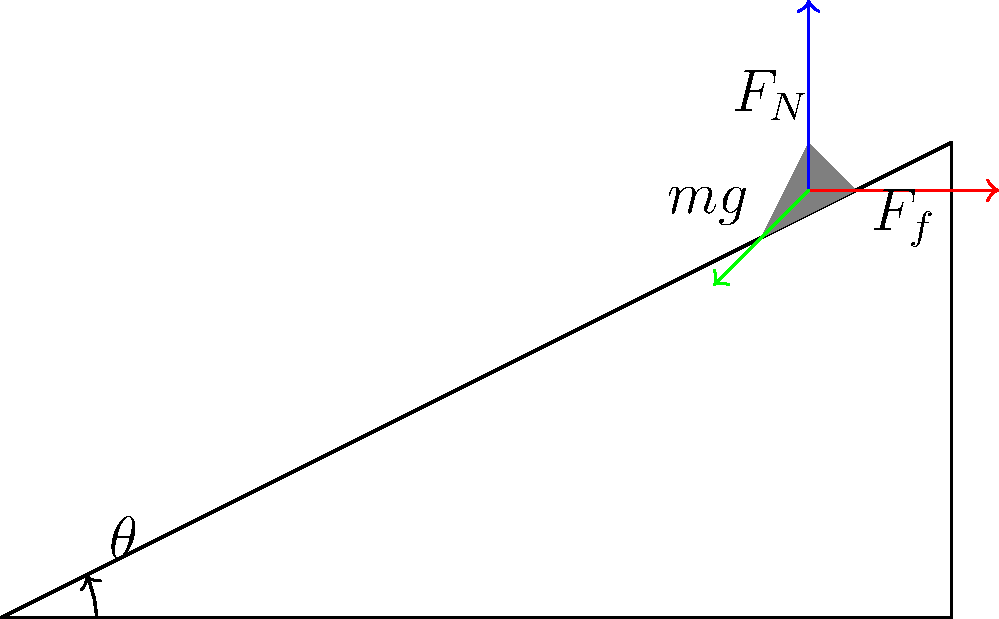In a protest rally, a megaphone is placed on an inclined surface with an angle $\theta$ to the horizontal. The mass of the megaphone is $m$. If the coefficient of static friction between the megaphone and the surface is $\mu_s$, what is the minimum angle $\theta$ at which the megaphone will start to slide down the inclined surface? To solve this problem, we need to analyze the forces acting on the megaphone and use the condition for impending motion. Let's break it down step-by-step:

1) The forces acting on the megaphone are:
   - Weight ($mg$) acting downwards
   - Normal force ($F_N$) perpendicular to the surface
   - Friction force ($F_f$) parallel to the surface, opposing motion

2) We can resolve the weight into components parallel and perpendicular to the inclined surface:
   - Component parallel to the surface: $mg \sin\theta$
   - Component perpendicular to the surface: $mg \cos\theta$

3) For equilibrium in the direction perpendicular to the surface:
   $F_N = mg \cos\theta$

4) The maximum static friction force is given by:
   $F_f = \mu_s F_N = \mu_s mg \cos\theta$

5) At the point of impending motion, the component of weight parallel to the surface is equal to the maximum static friction:
   $mg \sin\theta = \mu_s mg \cos\theta$

6) Simplifying this equation:
   $\tan\theta = \mu_s$

7) Therefore, the minimum angle at which sliding begins is:
   $\theta = \arctan(\mu_s)$

This angle represents the minimum inclination at which the component of the megaphone's weight parallel to the surface overcomes the maximum static friction force.
Answer: $\theta = \arctan(\mu_s)$ 